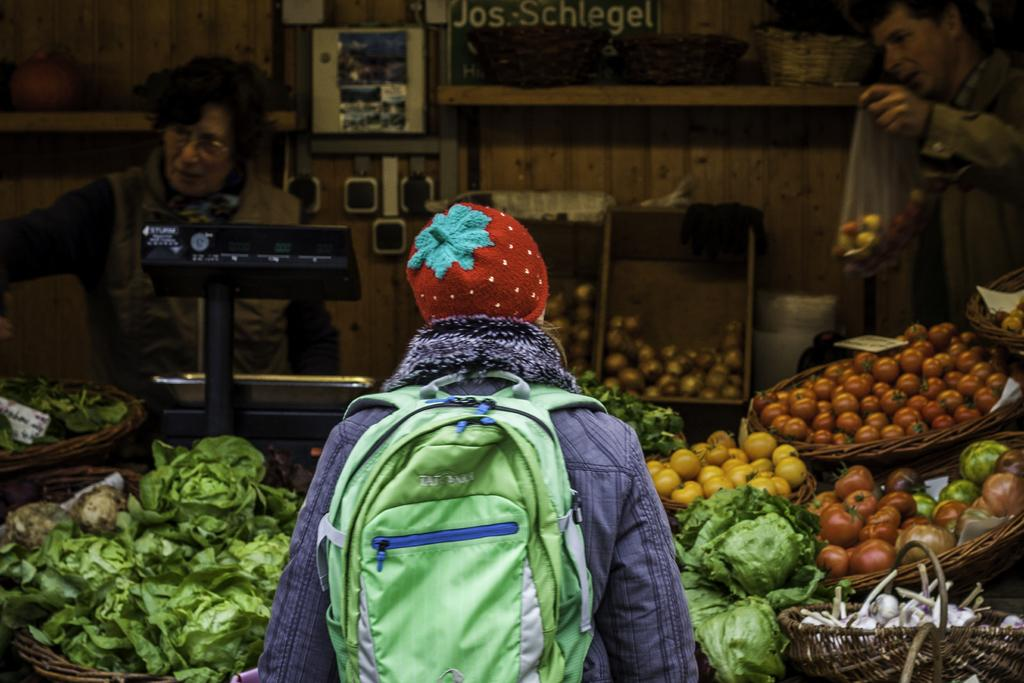What is the person in the image doing? The person in the image is standing and carrying a bag. What type of establishment can be seen in the image? There is a vegetable shop in the image. How many people are inside the vegetable shop? There are two persons standing in the vegetable shop. What can be found in the vegetable shop? There are vegetables visible in the image. What type of ray is flying over the vegetable shop in the image? There is no ray present in the image; it is a person standing and carrying a bag, and there is a vegetable shop with people inside. 